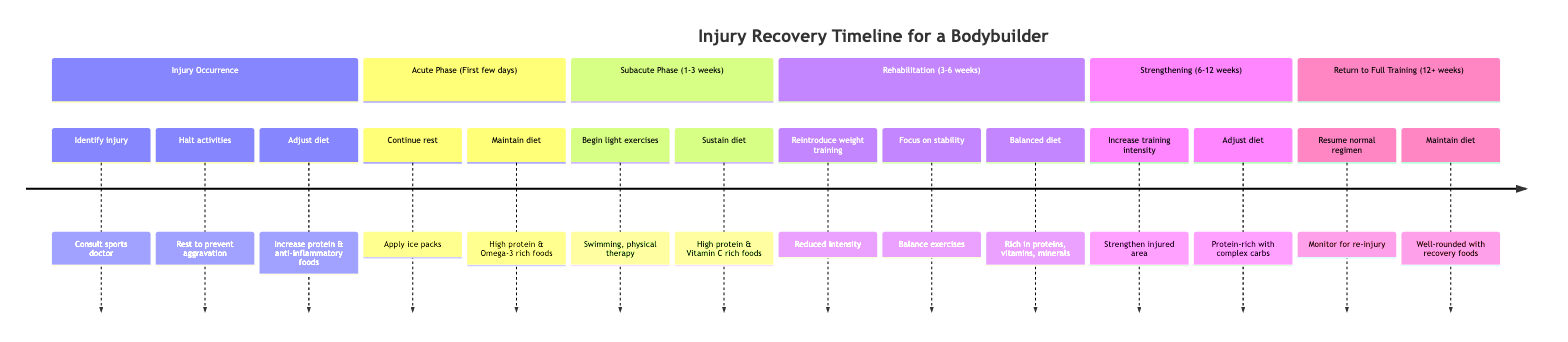What is the first phase in the timeline? The first phase in the timeline, as listed at the top, is "Injury Occurrence." It is the beginning stage of the timeline, indicating the starting point of injury management.
Answer: Injury Occurrence What dietary adjustment is suggested during the Acute Phase? During the Acute Phase, the diet should maintain high protein and introduce Omega-3 rich foods, which are noted to help with anti-inflammatory properties.
Answer: High protein & Omega-3 rich foods How long does the Subacute Phase last? The Subacute Phase lasts from 1 to 3 weeks post-injury, clearly indicated in the phase description.
Answer: 1-3 weeks What activities are recommended for the Rehabilitation Phase? The activities recommended for the Rehabilitation Phase include reintroducing weight training with reduced intensity and focusing on stability and balance exercises. These are outlined as key activities in this phase.
Answer: Reintroduce weight training & stability exercises What adjustment is made to the diet in the Strengthening Phase? The diet in the Strengthening Phase should be protein-rich with complex carbohydrates, as specified in the dietary adjustments for this phase, aimed at fueling increased workouts.
Answer: Protein-rich with complex carbohydrates What is a primary focus during the Strengthening Phase? The primary focus during the Strengthening Phase is to gradually increase the intensity of weight training sessions while emphasizing strengthening the injured area specifically. This goal is highlighted in the activities listed.
Answer: Increase intensity & strengthen injured area In which phase do light exercises such as swimming begin? Light exercises like swimming begin in the Subacute Phase, as indicated when discussing activities for this phase.
Answer: Subacute Phase What type of foods should be avoided during the Acute Phase? During the Acute Phase, it is advised to avoid processed items that do not contribute to recovery, as indicated in the dietary adjustments for this phase.
Answer: Processed items What dietary adjustments are recommended upon returning to full training? Upon returning to full training, the dietary adjustments include maintaining a well-rounded diet with recovery foods, which supports overall performance and recovery post-workout.
Answer: Well-rounded with recovery foods 